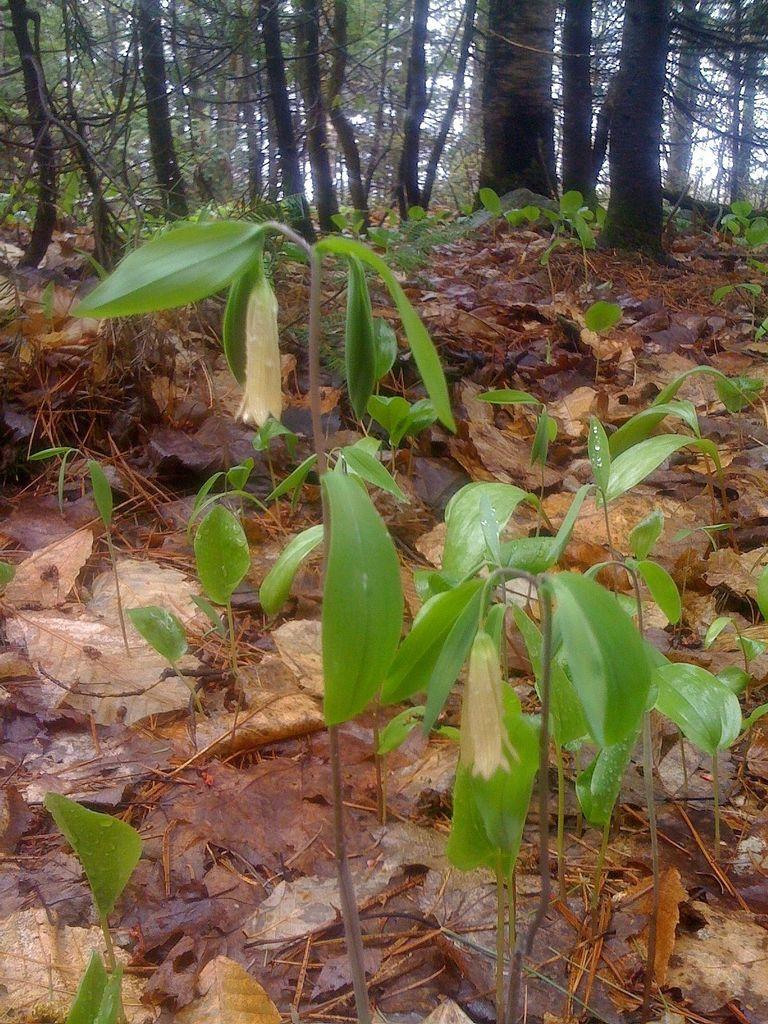What type of living organisms can be seen in the image? Plants can be seen in the image. What can be found on the ground in the image? Dried leaves are present on the ground in the image. What is visible in the background of the image? There are trees in the background of the image. What type of lumber is being used to construct the religious building in the image? There is no religious building or lumber present in the image. What type of beast can be seen roaming in the background of the image? There are no beasts present in the image; it features plants, dried leaves, and trees. 